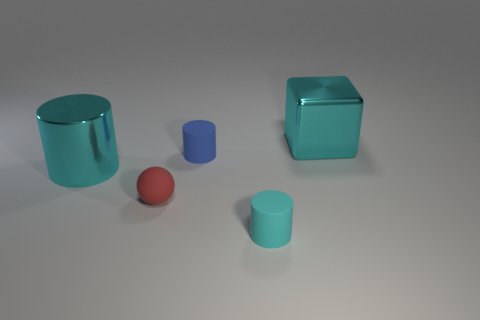Do the red object and the cyan metal object that is to the right of the large metallic cylinder have the same size?
Give a very brief answer. No. What color is the large cylinder that is behind the tiny matte ball?
Your answer should be compact. Cyan. What number of purple objects are either large metallic cylinders or balls?
Offer a terse response. 0. What is the color of the rubber ball?
Your answer should be compact. Red. Is the number of small blue matte things that are on the left side of the tiny blue cylinder less than the number of tiny red rubber objects in front of the ball?
Your response must be concise. No. The thing that is in front of the blue rubber cylinder and to the right of the red rubber sphere has what shape?
Your response must be concise. Cylinder. What number of blue objects are the same shape as the red matte thing?
Your response must be concise. 0. What size is the blue thing that is the same material as the small red object?
Your answer should be very brief. Small. How many cyan objects have the same size as the red thing?
Offer a terse response. 1. What is the size of the rubber thing that is the same color as the shiny cylinder?
Make the answer very short. Small. 